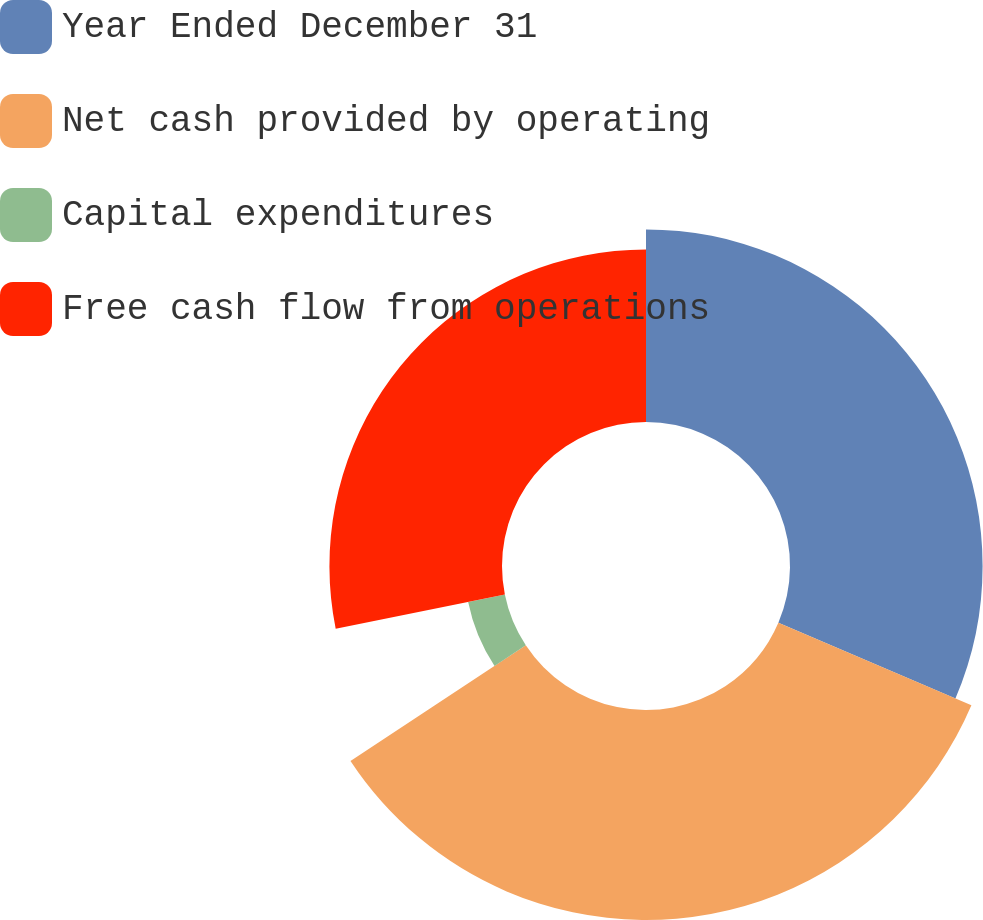Convert chart to OTSL. <chart><loc_0><loc_0><loc_500><loc_500><pie_chart><fcel>Year Ended December 31<fcel>Net cash provided by operating<fcel>Capital expenditures<fcel>Free cash flow from operations<nl><fcel>31.44%<fcel>34.28%<fcel>6.11%<fcel>28.17%<nl></chart> 